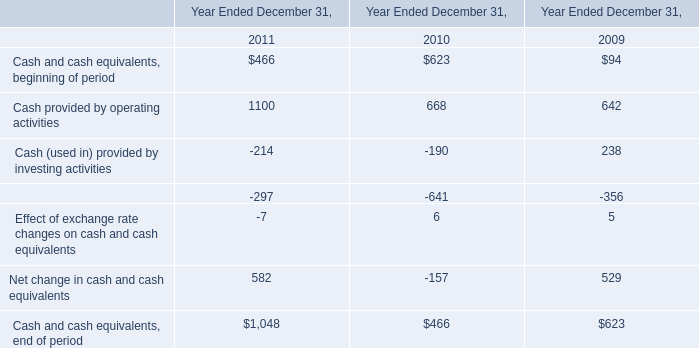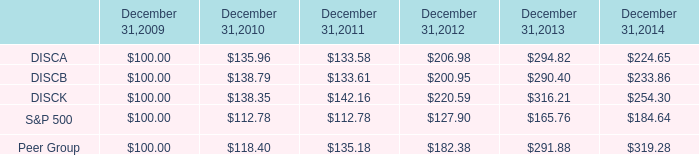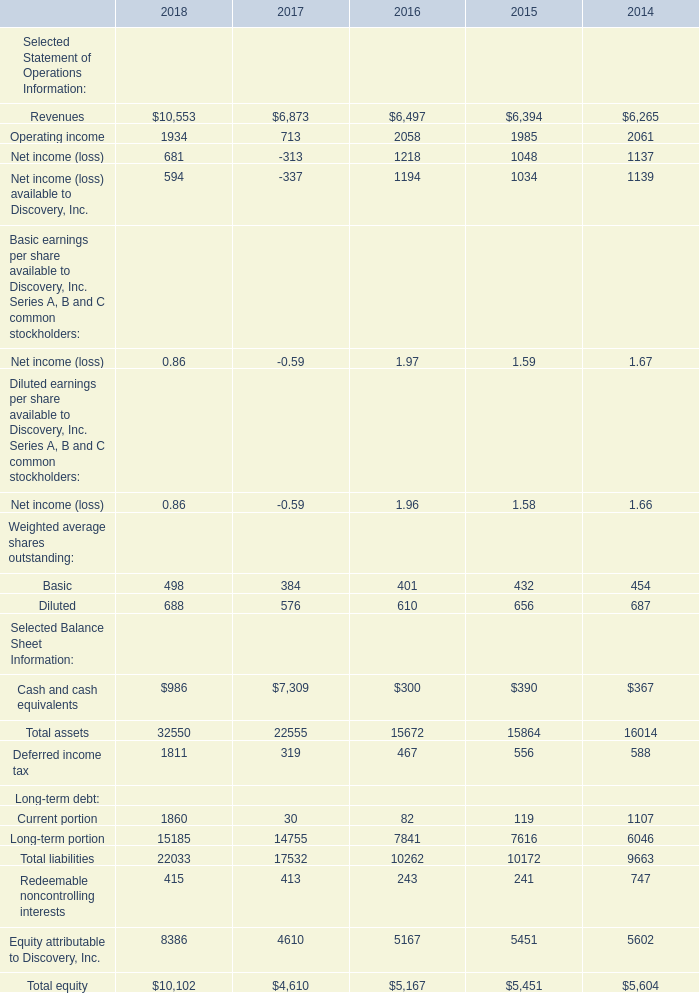What was the average of Revenue in 2018, 2017, and 2016? 
Computations: (((10553 + 6873) + 6497) / 3)
Answer: 7974.33333. 